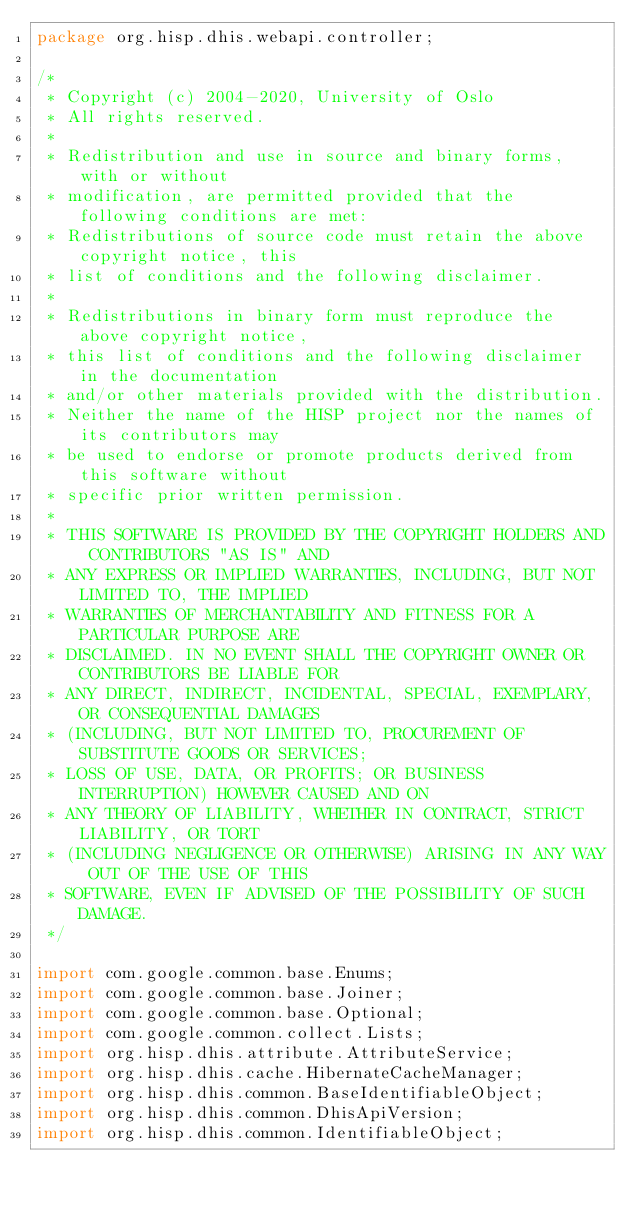Convert code to text. <code><loc_0><loc_0><loc_500><loc_500><_Java_>package org.hisp.dhis.webapi.controller;

/*
 * Copyright (c) 2004-2020, University of Oslo
 * All rights reserved.
 *
 * Redistribution and use in source and binary forms, with or without
 * modification, are permitted provided that the following conditions are met:
 * Redistributions of source code must retain the above copyright notice, this
 * list of conditions and the following disclaimer.
 *
 * Redistributions in binary form must reproduce the above copyright notice,
 * this list of conditions and the following disclaimer in the documentation
 * and/or other materials provided with the distribution.
 * Neither the name of the HISP project nor the names of its contributors may
 * be used to endorse or promote products derived from this software without
 * specific prior written permission.
 *
 * THIS SOFTWARE IS PROVIDED BY THE COPYRIGHT HOLDERS AND CONTRIBUTORS "AS IS" AND
 * ANY EXPRESS OR IMPLIED WARRANTIES, INCLUDING, BUT NOT LIMITED TO, THE IMPLIED
 * WARRANTIES OF MERCHANTABILITY AND FITNESS FOR A PARTICULAR PURPOSE ARE
 * DISCLAIMED. IN NO EVENT SHALL THE COPYRIGHT OWNER OR CONTRIBUTORS BE LIABLE FOR
 * ANY DIRECT, INDIRECT, INCIDENTAL, SPECIAL, EXEMPLARY, OR CONSEQUENTIAL DAMAGES
 * (INCLUDING, BUT NOT LIMITED TO, PROCUREMENT OF SUBSTITUTE GOODS OR SERVICES;
 * LOSS OF USE, DATA, OR PROFITS; OR BUSINESS INTERRUPTION) HOWEVER CAUSED AND ON
 * ANY THEORY OF LIABILITY, WHETHER IN CONTRACT, STRICT LIABILITY, OR TORT
 * (INCLUDING NEGLIGENCE OR OTHERWISE) ARISING IN ANY WAY OUT OF THE USE OF THIS
 * SOFTWARE, EVEN IF ADVISED OF THE POSSIBILITY OF SUCH DAMAGE.
 */

import com.google.common.base.Enums;
import com.google.common.base.Joiner;
import com.google.common.base.Optional;
import com.google.common.collect.Lists;
import org.hisp.dhis.attribute.AttributeService;
import org.hisp.dhis.cache.HibernateCacheManager;
import org.hisp.dhis.common.BaseIdentifiableObject;
import org.hisp.dhis.common.DhisApiVersion;
import org.hisp.dhis.common.IdentifiableObject;</code> 